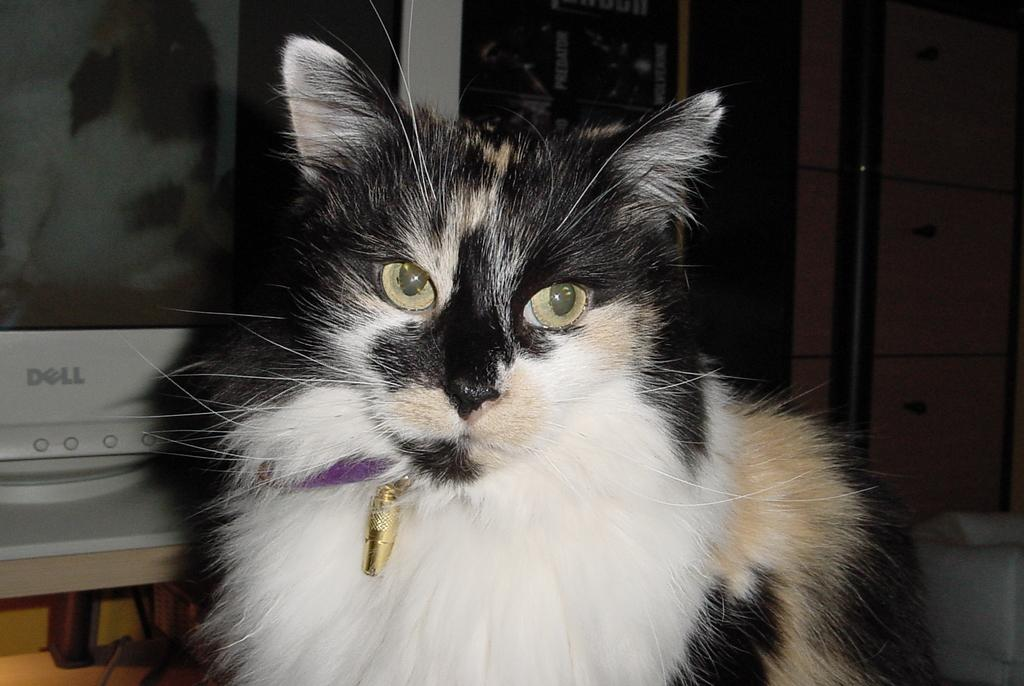Provide a one-sentence caption for the provided image. A cat sits in front of a Dell monitor. 